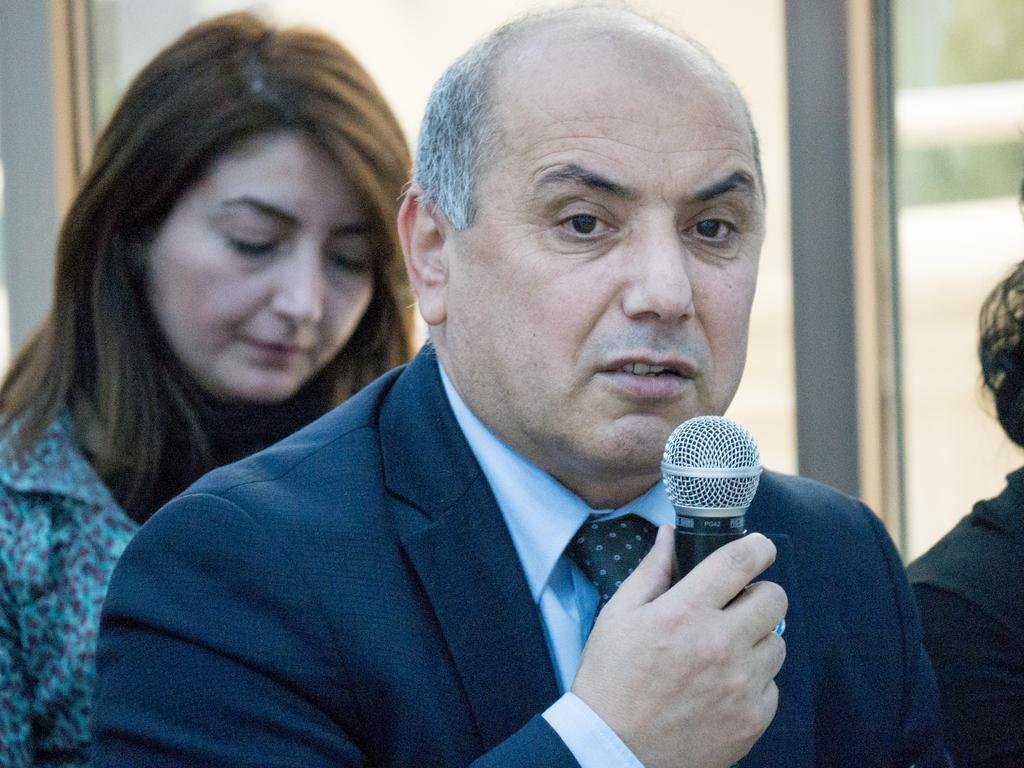Who is the main subject in the image? There is a man in the center of the image. What is the man holding in his right hand? The man is holding a microphone in his right hand. What is the man doing in the image? The man is speaking. Can you describe the woman in the background of the image? There is a woman in the background of the image, and she is on the left side. What type of wing is visible on the man's chin in the image? There is no wing visible on the man's chin in the image. What type of books can be seen in the library in the image? There is no library present in the image. 